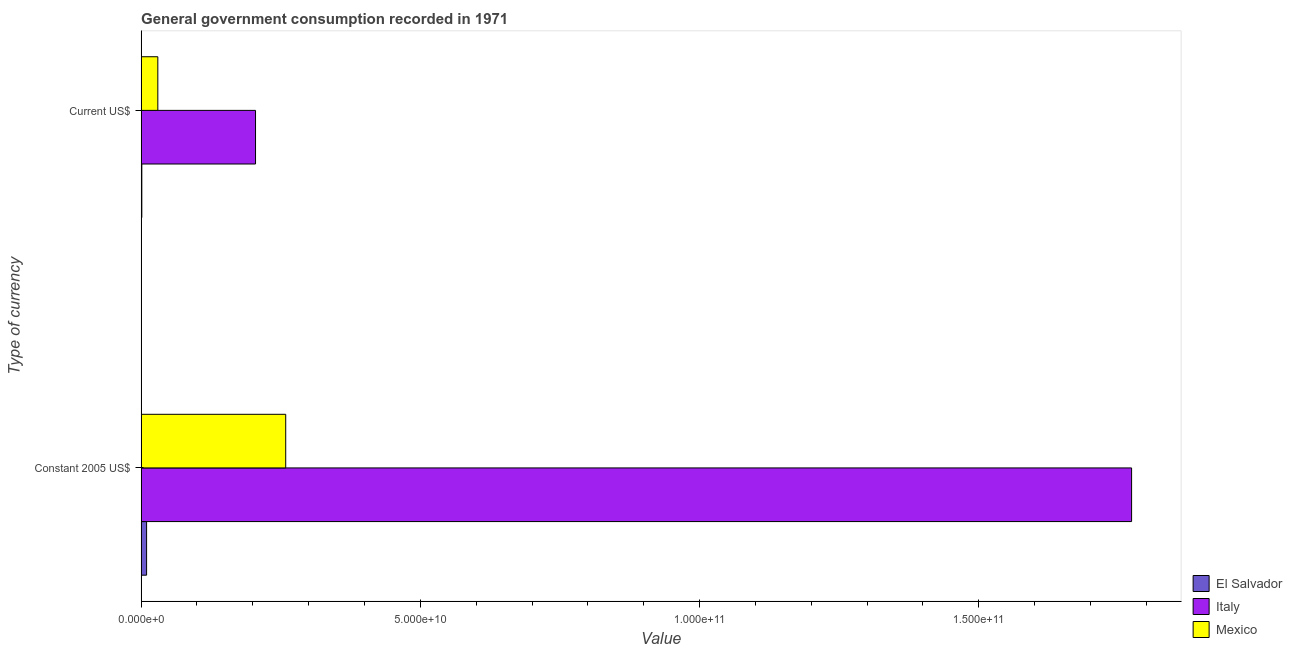How many different coloured bars are there?
Provide a succinct answer. 3. Are the number of bars on each tick of the Y-axis equal?
Make the answer very short. Yes. How many bars are there on the 2nd tick from the bottom?
Keep it short and to the point. 3. What is the label of the 2nd group of bars from the top?
Your answer should be very brief. Constant 2005 US$. What is the value consumed in constant 2005 us$ in Italy?
Provide a short and direct response. 1.77e+11. Across all countries, what is the maximum value consumed in current us$?
Ensure brevity in your answer.  2.05e+1. Across all countries, what is the minimum value consumed in constant 2005 us$?
Your response must be concise. 9.75e+08. In which country was the value consumed in current us$ minimum?
Your answer should be very brief. El Salvador. What is the total value consumed in constant 2005 us$ in the graph?
Provide a short and direct response. 2.04e+11. What is the difference between the value consumed in current us$ in Mexico and that in El Salvador?
Provide a succinct answer. 2.87e+09. What is the difference between the value consumed in current us$ in El Salvador and the value consumed in constant 2005 us$ in Italy?
Provide a succinct answer. -1.77e+11. What is the average value consumed in current us$ per country?
Make the answer very short. 7.86e+09. What is the difference between the value consumed in constant 2005 us$ and value consumed in current us$ in Mexico?
Ensure brevity in your answer.  2.29e+1. In how many countries, is the value consumed in current us$ greater than 40000000000 ?
Offer a terse response. 0. What is the ratio of the value consumed in constant 2005 us$ in Italy to that in Mexico?
Provide a short and direct response. 6.85. In how many countries, is the value consumed in current us$ greater than the average value consumed in current us$ taken over all countries?
Keep it short and to the point. 1. What does the 3rd bar from the top in Constant 2005 US$ represents?
Make the answer very short. El Salvador. What does the 3rd bar from the bottom in Current US$ represents?
Make the answer very short. Mexico. How many bars are there?
Offer a very short reply. 6. How many countries are there in the graph?
Provide a short and direct response. 3. Does the graph contain any zero values?
Provide a short and direct response. No. How many legend labels are there?
Your answer should be compact. 3. How are the legend labels stacked?
Your answer should be very brief. Vertical. What is the title of the graph?
Offer a terse response. General government consumption recorded in 1971. Does "Malaysia" appear as one of the legend labels in the graph?
Offer a very short reply. No. What is the label or title of the X-axis?
Provide a short and direct response. Value. What is the label or title of the Y-axis?
Keep it short and to the point. Type of currency. What is the Value of El Salvador in Constant 2005 US$?
Your answer should be compact. 9.75e+08. What is the Value of Italy in Constant 2005 US$?
Offer a very short reply. 1.77e+11. What is the Value in Mexico in Constant 2005 US$?
Make the answer very short. 2.59e+1. What is the Value of El Salvador in Current US$?
Ensure brevity in your answer.  1.21e+08. What is the Value in Italy in Current US$?
Ensure brevity in your answer.  2.05e+1. What is the Value of Mexico in Current US$?
Offer a terse response. 2.99e+09. Across all Type of currency, what is the maximum Value in El Salvador?
Make the answer very short. 9.75e+08. Across all Type of currency, what is the maximum Value in Italy?
Provide a succinct answer. 1.77e+11. Across all Type of currency, what is the maximum Value in Mexico?
Your response must be concise. 2.59e+1. Across all Type of currency, what is the minimum Value of El Salvador?
Your response must be concise. 1.21e+08. Across all Type of currency, what is the minimum Value of Italy?
Offer a terse response. 2.05e+1. Across all Type of currency, what is the minimum Value of Mexico?
Ensure brevity in your answer.  2.99e+09. What is the total Value of El Salvador in the graph?
Your response must be concise. 1.10e+09. What is the total Value in Italy in the graph?
Offer a very short reply. 1.98e+11. What is the total Value in Mexico in the graph?
Offer a terse response. 2.89e+1. What is the difference between the Value in El Salvador in Constant 2005 US$ and that in Current US$?
Ensure brevity in your answer.  8.55e+08. What is the difference between the Value of Italy in Constant 2005 US$ and that in Current US$?
Your answer should be compact. 1.57e+11. What is the difference between the Value in Mexico in Constant 2005 US$ and that in Current US$?
Provide a succinct answer. 2.29e+1. What is the difference between the Value of El Salvador in Constant 2005 US$ and the Value of Italy in Current US$?
Your response must be concise. -1.95e+1. What is the difference between the Value of El Salvador in Constant 2005 US$ and the Value of Mexico in Current US$?
Your response must be concise. -2.01e+09. What is the difference between the Value in Italy in Constant 2005 US$ and the Value in Mexico in Current US$?
Offer a very short reply. 1.74e+11. What is the average Value in El Salvador per Type of currency?
Offer a terse response. 5.48e+08. What is the average Value in Italy per Type of currency?
Offer a terse response. 9.89e+1. What is the average Value of Mexico per Type of currency?
Ensure brevity in your answer.  1.44e+1. What is the difference between the Value in El Salvador and Value in Italy in Constant 2005 US$?
Your answer should be very brief. -1.76e+11. What is the difference between the Value of El Salvador and Value of Mexico in Constant 2005 US$?
Your answer should be very brief. -2.49e+1. What is the difference between the Value in Italy and Value in Mexico in Constant 2005 US$?
Offer a terse response. 1.51e+11. What is the difference between the Value of El Salvador and Value of Italy in Current US$?
Provide a succinct answer. -2.04e+1. What is the difference between the Value of El Salvador and Value of Mexico in Current US$?
Your answer should be very brief. -2.87e+09. What is the difference between the Value of Italy and Value of Mexico in Current US$?
Ensure brevity in your answer.  1.75e+1. What is the ratio of the Value in El Salvador in Constant 2005 US$ to that in Current US$?
Provide a succinct answer. 8.09. What is the ratio of the Value of Italy in Constant 2005 US$ to that in Current US$?
Keep it short and to the point. 8.66. What is the ratio of the Value of Mexico in Constant 2005 US$ to that in Current US$?
Give a very brief answer. 8.67. What is the difference between the highest and the second highest Value of El Salvador?
Give a very brief answer. 8.55e+08. What is the difference between the highest and the second highest Value in Italy?
Offer a very short reply. 1.57e+11. What is the difference between the highest and the second highest Value of Mexico?
Your answer should be compact. 2.29e+1. What is the difference between the highest and the lowest Value in El Salvador?
Keep it short and to the point. 8.55e+08. What is the difference between the highest and the lowest Value of Italy?
Your answer should be compact. 1.57e+11. What is the difference between the highest and the lowest Value of Mexico?
Offer a very short reply. 2.29e+1. 